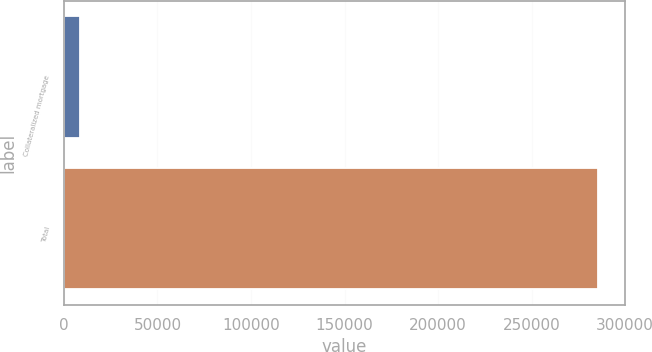<chart> <loc_0><loc_0><loc_500><loc_500><bar_chart><fcel>Collateralized mortgage<fcel>Total<nl><fcel>8370<fcel>285717<nl></chart> 